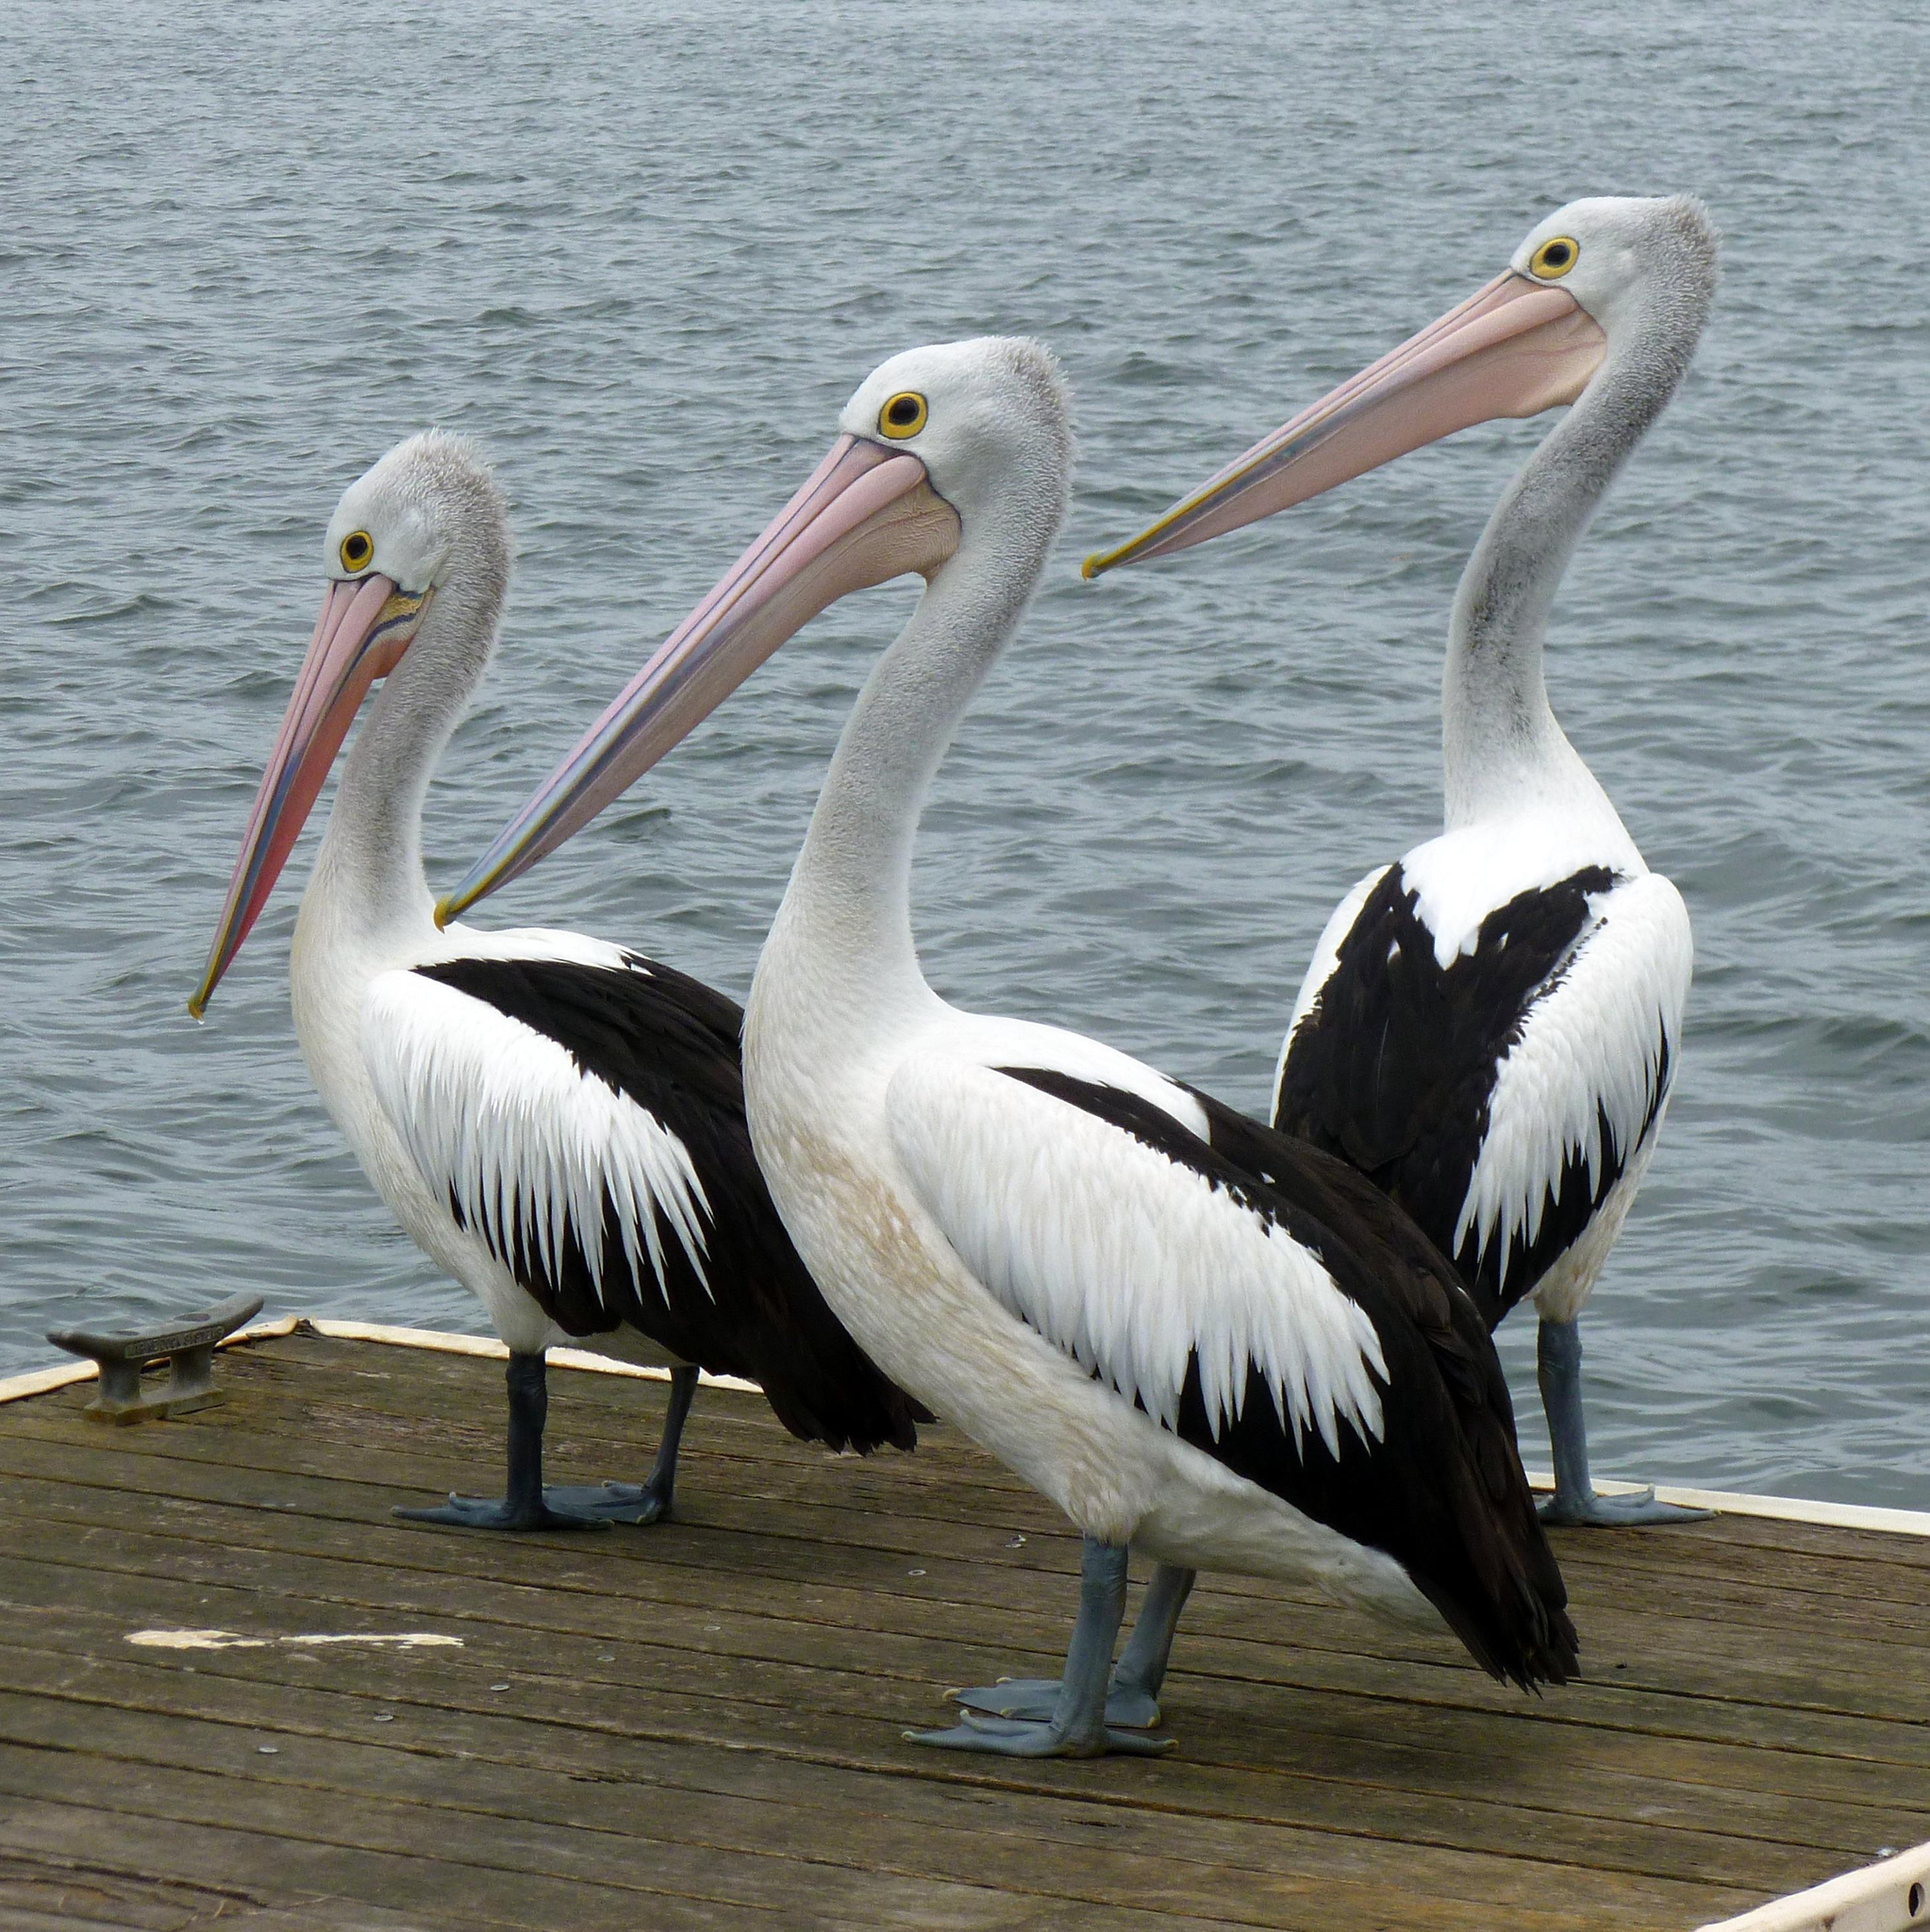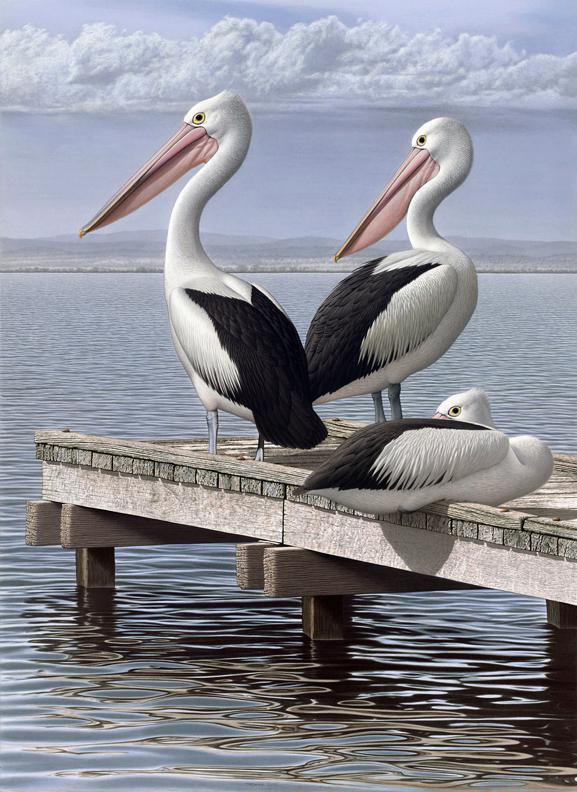The first image is the image on the left, the second image is the image on the right. Given the left and right images, does the statement "One of the images contains a single bird only." hold true? Answer yes or no. No. The first image is the image on the left, the second image is the image on the right. For the images shown, is this caption "There are at least three birds standing on a dock." true? Answer yes or no. Yes. 